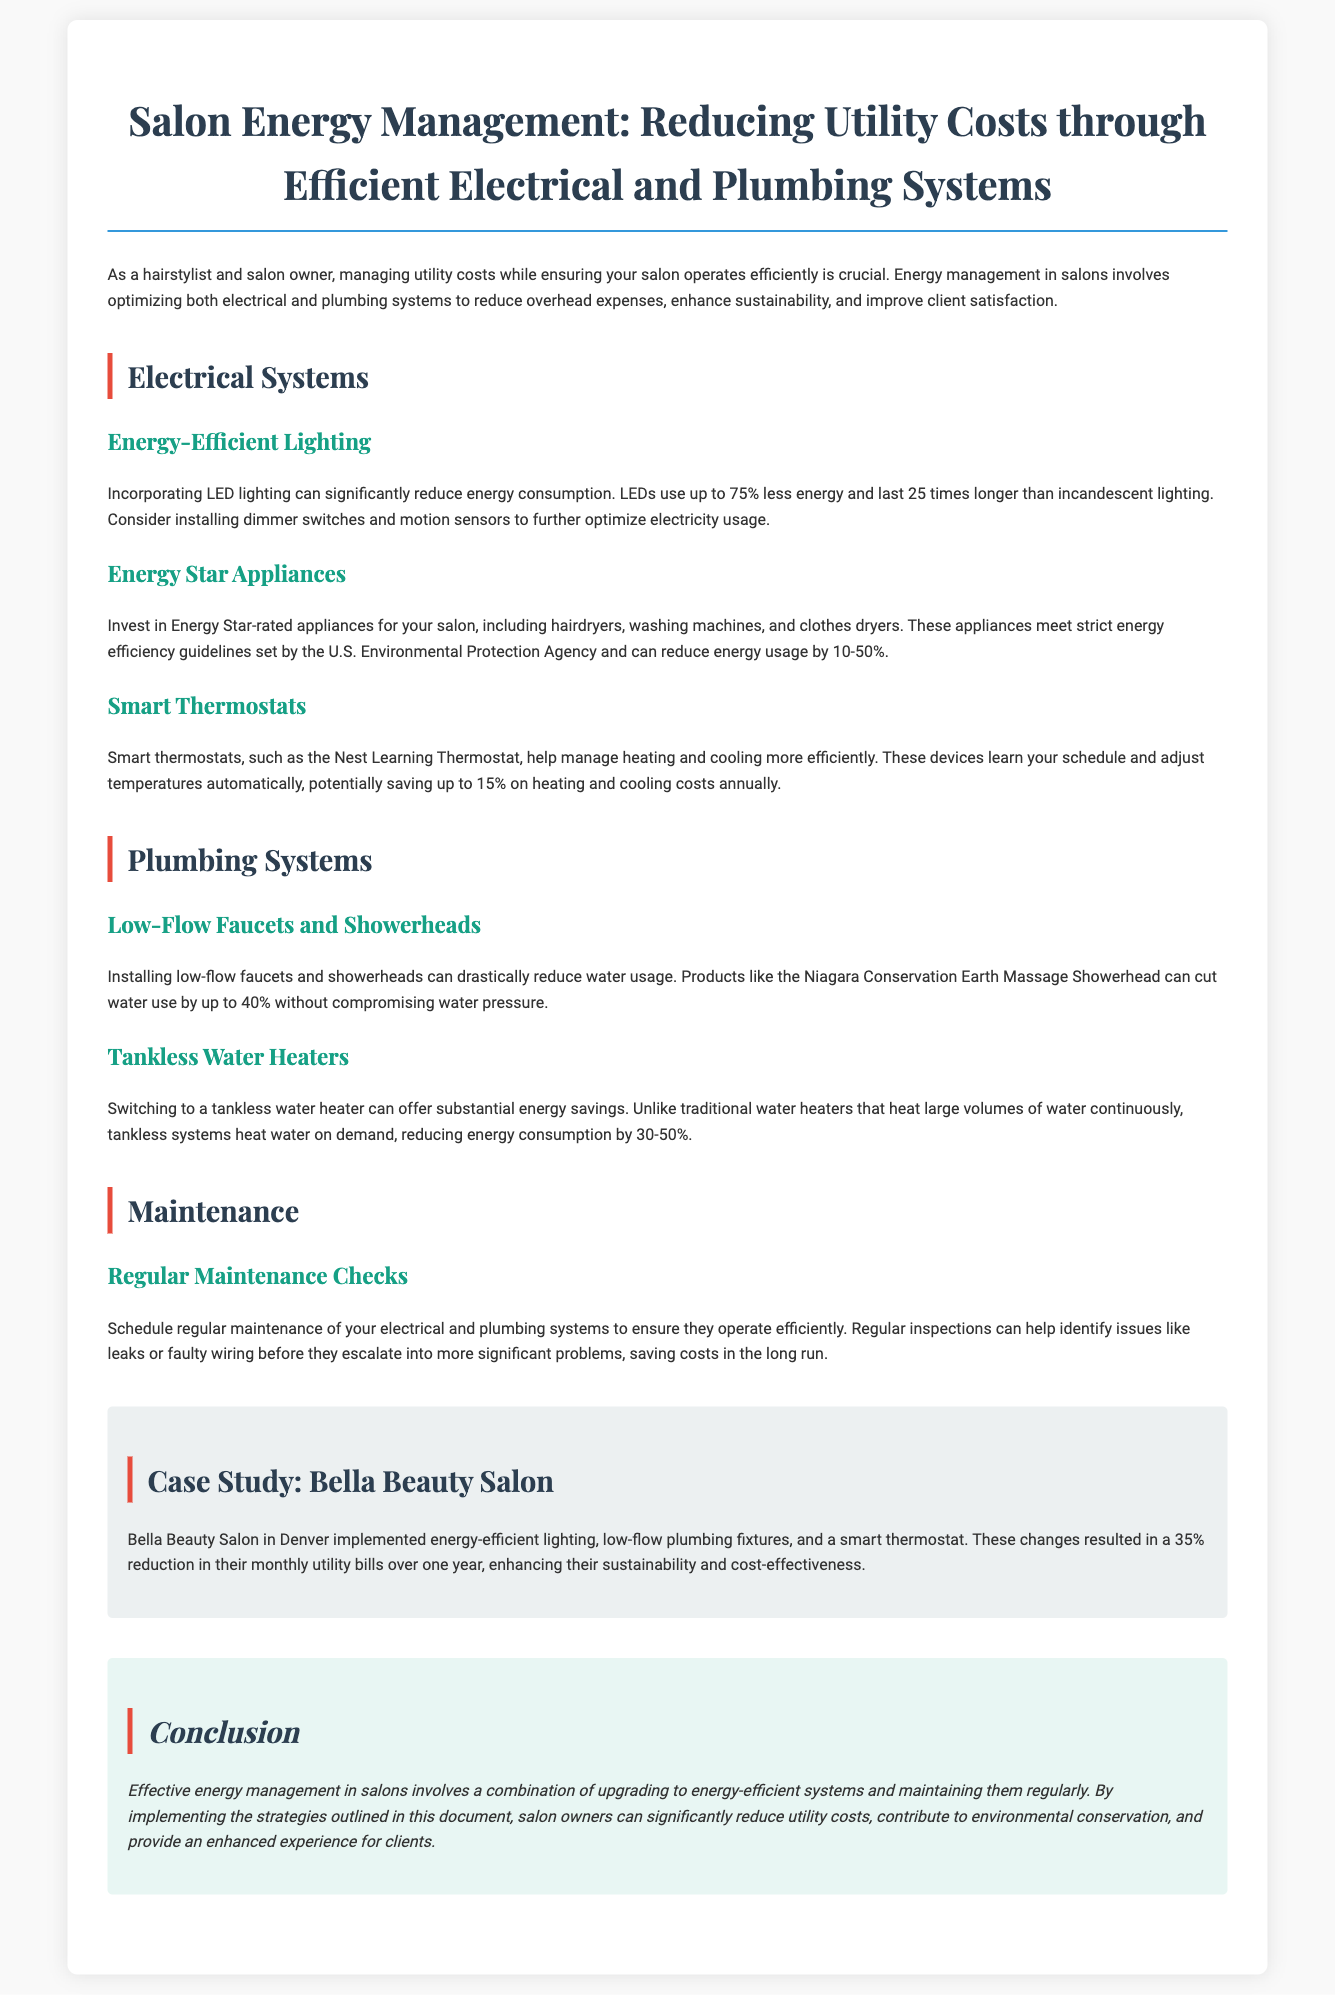What is the main focus of the whitepaper? The main focus of the whitepaper is energy management in salons, specifically reducing utility costs through efficient electrical and plumbing systems.
Answer: energy management What percentage less energy do LEDs use compared to incandescent lighting? The document states that LEDs use up to 75% less energy compared to incandescent lighting.
Answer: 75% What is one benefit of Energy Star appliances? The document says that Energy Star appliances can reduce energy usage by 10-50%.
Answer: 10-50% How much can smart thermostats potentially save on heating and cooling costs annually? The document mentions that smart thermostats can potentially save up to 15% on heating and cooling costs annually.
Answer: 15% What type of water heater can reduce energy consumption by 30-50%? According to the document, switching to a tankless water heater can reduce energy consumption by 30-50%.
Answer: tankless water heater What significant change did Bella Beauty Salon implement? Bella Beauty Salon implemented energy-efficient lighting, low-flow plumbing fixtures, and a smart thermostat.
Answer: energy-efficient lighting, low-flow plumbing fixtures, smart thermostat Why is regular maintenance important for electrical and plumbing systems? The document explains that regular maintenance is important to ensure systems operate efficiently and to identify issues before they escalate.
Answer: to ensure efficiency and identify issues What does the conclusion recommend for salon owners? The conclusion recommends that salon owners implement the outlined strategies to reduce utility costs and enhance client experience.
Answer: implement outlined strategies 